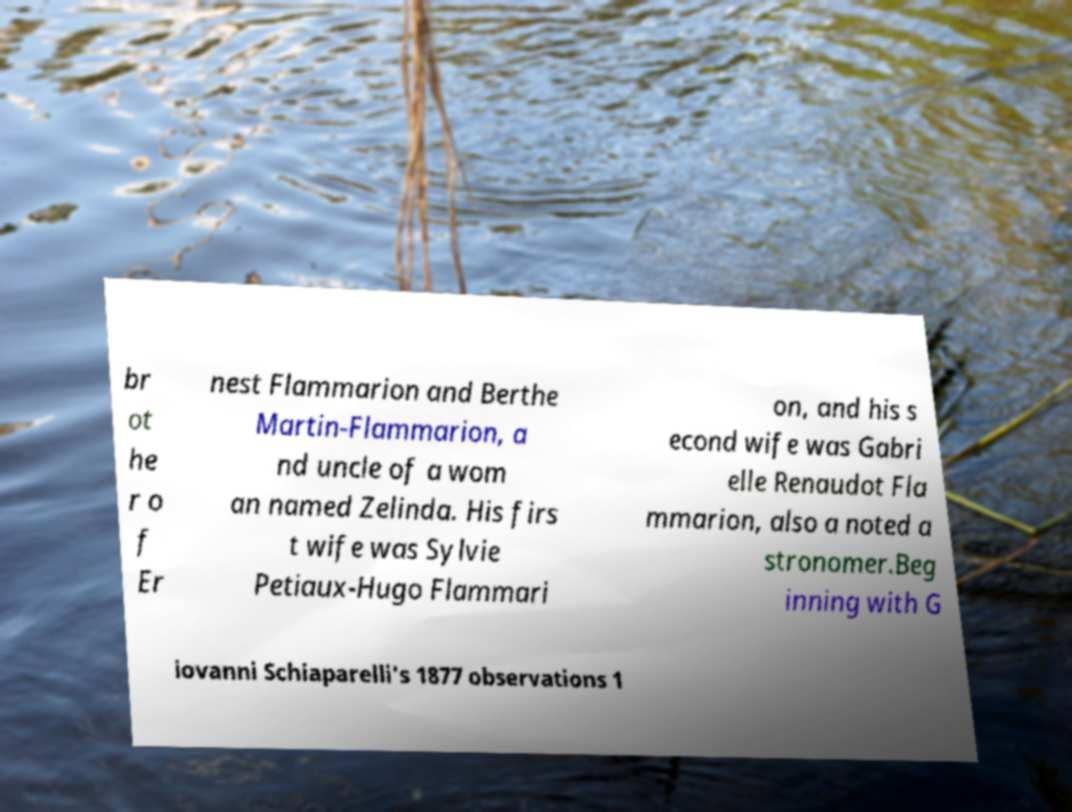Could you assist in decoding the text presented in this image and type it out clearly? br ot he r o f Er nest Flammarion and Berthe Martin-Flammarion, a nd uncle of a wom an named Zelinda. His firs t wife was Sylvie Petiaux-Hugo Flammari on, and his s econd wife was Gabri elle Renaudot Fla mmarion, also a noted a stronomer.Beg inning with G iovanni Schiaparelli's 1877 observations 1 